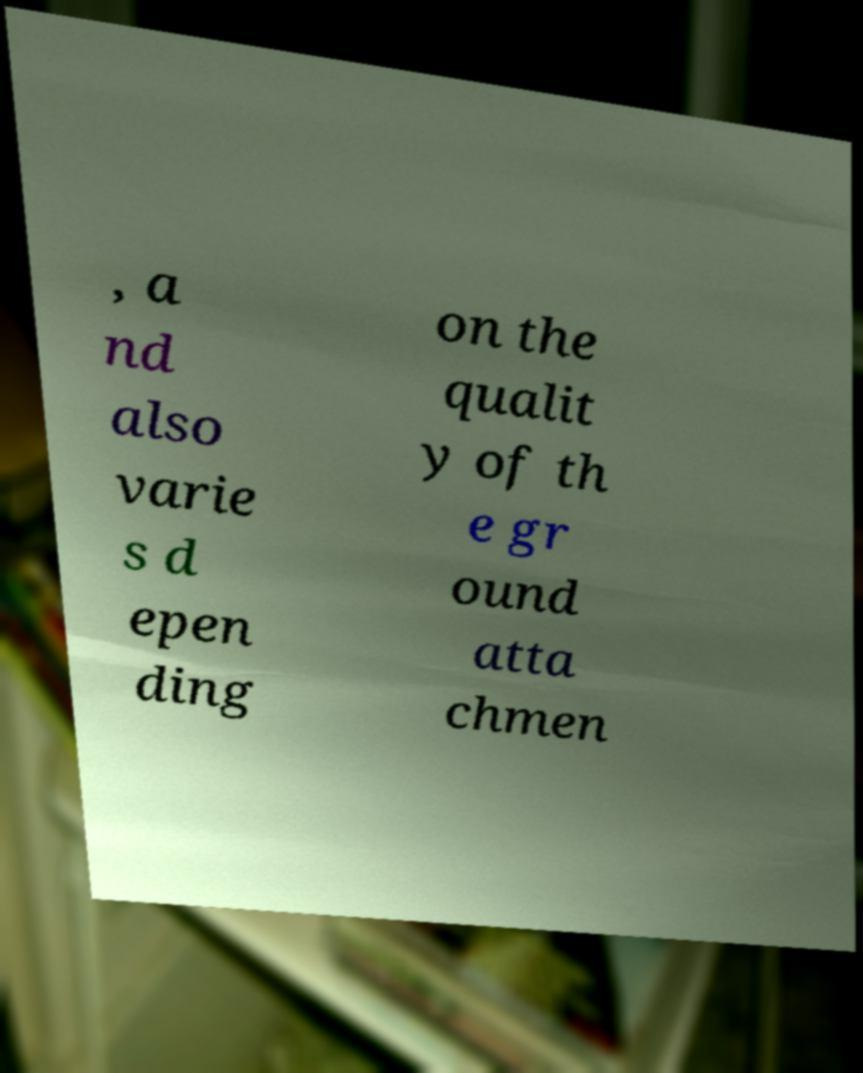Can you accurately transcribe the text from the provided image for me? , a nd also varie s d epen ding on the qualit y of th e gr ound atta chmen 